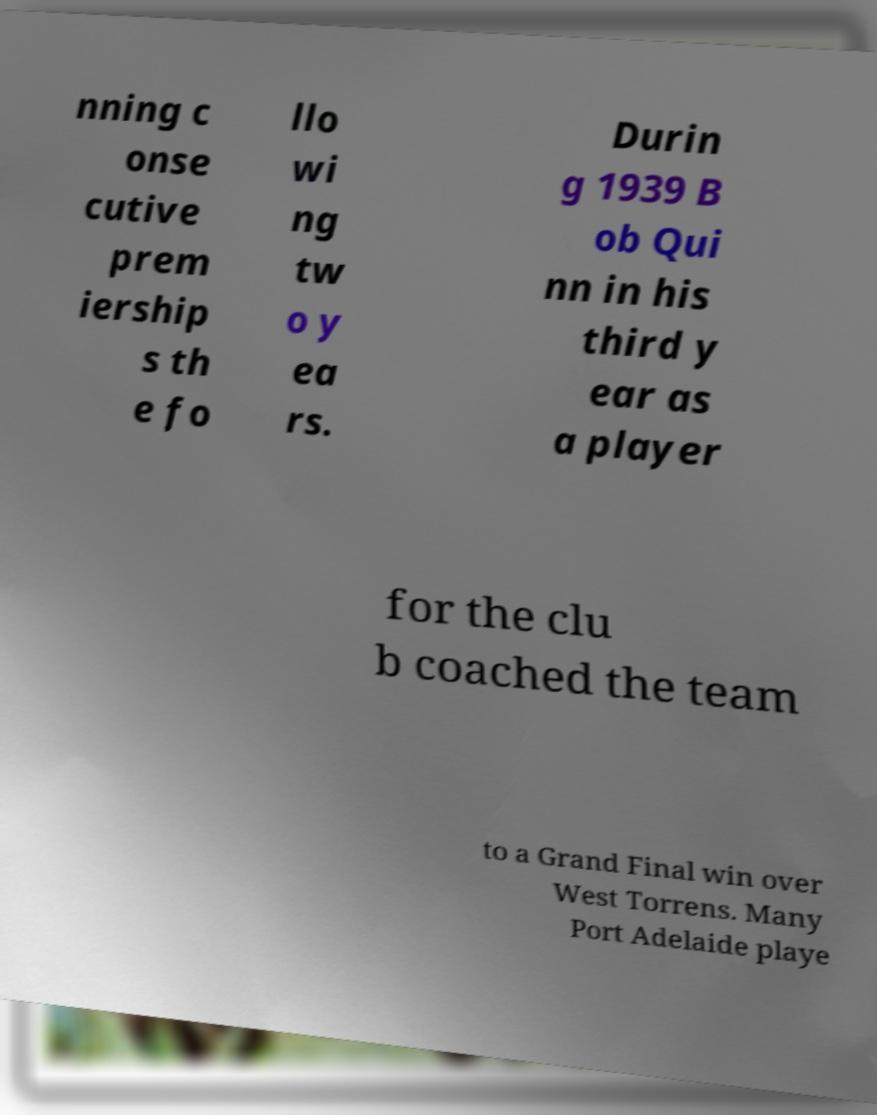There's text embedded in this image that I need extracted. Can you transcribe it verbatim? nning c onse cutive prem iership s th e fo llo wi ng tw o y ea rs. Durin g 1939 B ob Qui nn in his third y ear as a player for the clu b coached the team to a Grand Final win over West Torrens. Many Port Adelaide playe 